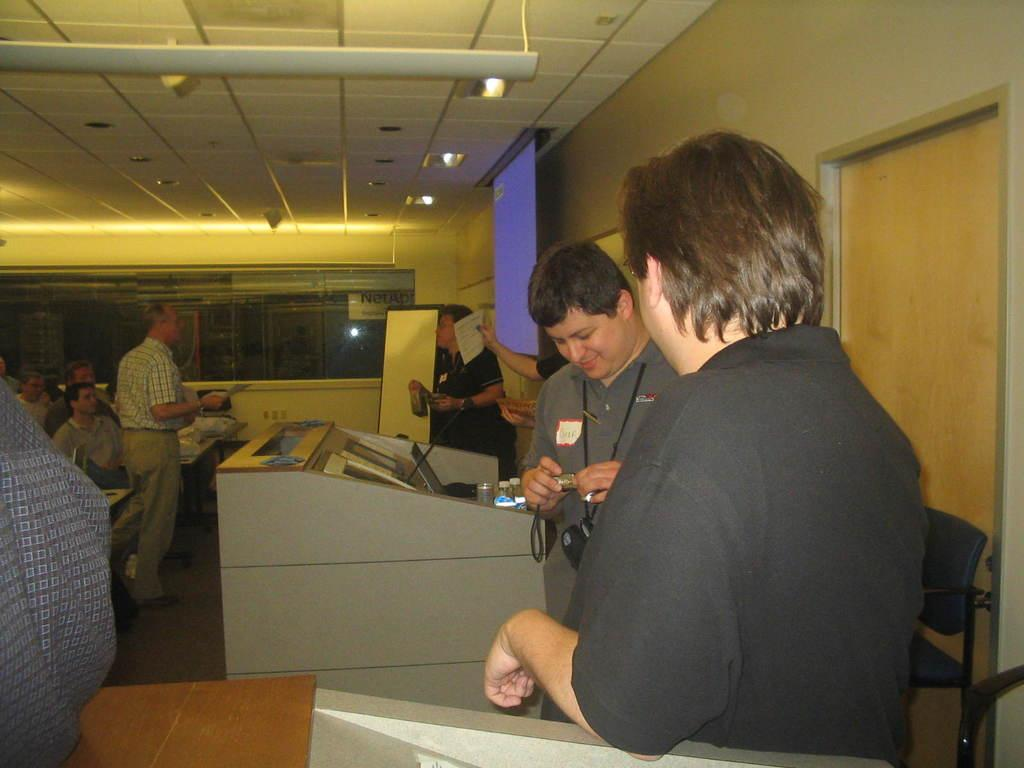What are the people in the image doing? Some people are standing, and some are seated on chairs in the image. What can be seen on the wall in the image? There is a projector screen on the wall in the image. What is the man in the image holding in his hand? The man is holding a camera in his hand in the image. What type of goldfish can be seen swimming in the jail in the image? There is no jail or goldfish present in the image. The image features people standing, seated individuals, a projector screen, and a man holding a camera. 